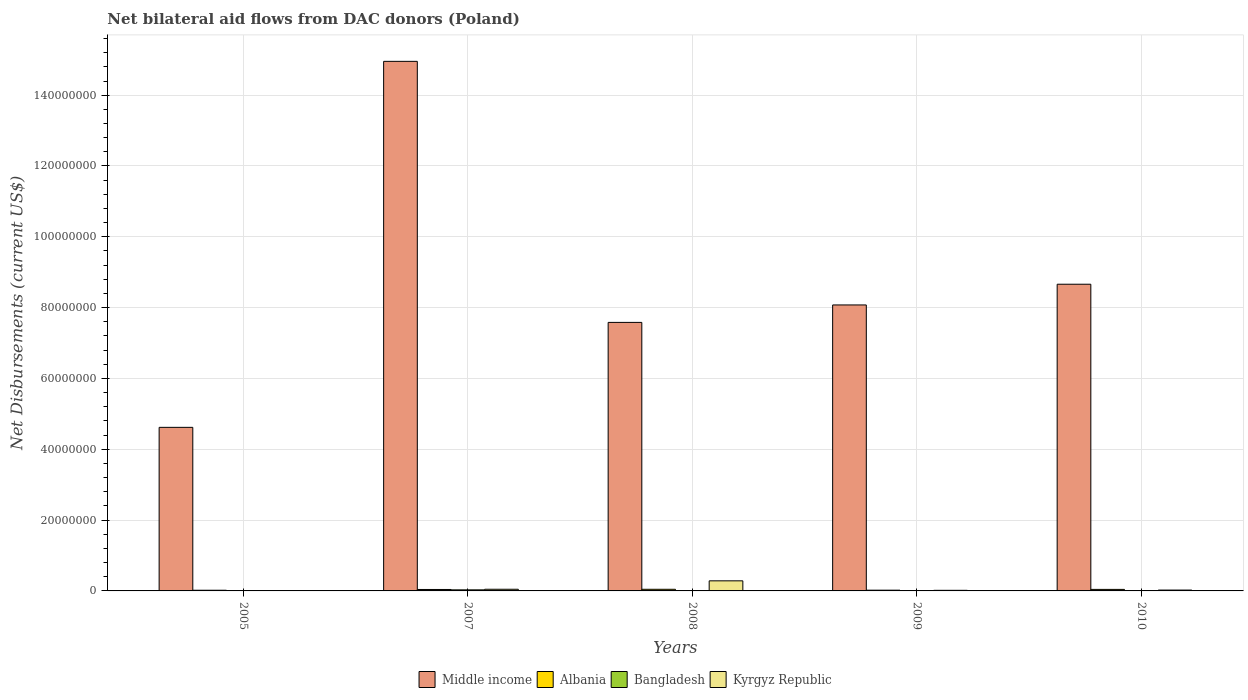How many different coloured bars are there?
Give a very brief answer. 4. How many groups of bars are there?
Keep it short and to the point. 5. Are the number of bars on each tick of the X-axis equal?
Your answer should be very brief. Yes. In how many cases, is the number of bars for a given year not equal to the number of legend labels?
Ensure brevity in your answer.  0. What is the net bilateral aid flows in Kyrgyz Republic in 2010?
Your answer should be compact. 2.40e+05. Across all years, what is the maximum net bilateral aid flows in Middle income?
Keep it short and to the point. 1.50e+08. Across all years, what is the minimum net bilateral aid flows in Albania?
Your answer should be compact. 1.90e+05. In which year was the net bilateral aid flows in Middle income maximum?
Your response must be concise. 2007. In which year was the net bilateral aid flows in Bangladesh minimum?
Give a very brief answer. 2005. What is the total net bilateral aid flows in Albania in the graph?
Offer a very short reply. 1.70e+06. What is the difference between the net bilateral aid flows in Middle income in 2008 and that in 2009?
Make the answer very short. -4.93e+06. What is the difference between the net bilateral aid flows in Kyrgyz Republic in 2007 and the net bilateral aid flows in Bangladesh in 2010?
Give a very brief answer. 4.20e+05. What is the average net bilateral aid flows in Bangladesh per year?
Ensure brevity in your answer.  9.60e+04. In the year 2009, what is the difference between the net bilateral aid flows in Albania and net bilateral aid flows in Middle income?
Ensure brevity in your answer.  -8.06e+07. In how many years, is the net bilateral aid flows in Albania greater than 52000000 US$?
Your response must be concise. 0. What is the ratio of the net bilateral aid flows in Bangladesh in 2007 to that in 2008?
Ensure brevity in your answer.  4.29. Is the net bilateral aid flows in Kyrgyz Republic in 2007 less than that in 2010?
Make the answer very short. No. Is the difference between the net bilateral aid flows in Albania in 2005 and 2007 greater than the difference between the net bilateral aid flows in Middle income in 2005 and 2007?
Give a very brief answer. Yes. Is the sum of the net bilateral aid flows in Middle income in 2009 and 2010 greater than the maximum net bilateral aid flows in Albania across all years?
Make the answer very short. Yes. What does the 2nd bar from the left in 2010 represents?
Provide a succinct answer. Albania. What does the 3rd bar from the right in 2008 represents?
Give a very brief answer. Albania. How many bars are there?
Offer a very short reply. 20. How many years are there in the graph?
Give a very brief answer. 5. Are the values on the major ticks of Y-axis written in scientific E-notation?
Make the answer very short. No. Does the graph contain grids?
Your answer should be very brief. Yes. How many legend labels are there?
Your response must be concise. 4. How are the legend labels stacked?
Your response must be concise. Horizontal. What is the title of the graph?
Keep it short and to the point. Net bilateral aid flows from DAC donors (Poland). Does "Tanzania" appear as one of the legend labels in the graph?
Offer a very short reply. No. What is the label or title of the X-axis?
Your answer should be compact. Years. What is the label or title of the Y-axis?
Ensure brevity in your answer.  Net Disbursements (current US$). What is the Net Disbursements (current US$) of Middle income in 2005?
Provide a succinct answer. 4.62e+07. What is the Net Disbursements (current US$) of Middle income in 2007?
Provide a succinct answer. 1.50e+08. What is the Net Disbursements (current US$) of Bangladesh in 2007?
Provide a succinct answer. 3.00e+05. What is the Net Disbursements (current US$) of Middle income in 2008?
Offer a terse response. 7.58e+07. What is the Net Disbursements (current US$) of Albania in 2008?
Provide a short and direct response. 4.60e+05. What is the Net Disbursements (current US$) of Kyrgyz Republic in 2008?
Provide a succinct answer. 2.85e+06. What is the Net Disbursements (current US$) in Middle income in 2009?
Keep it short and to the point. 8.08e+07. What is the Net Disbursements (current US$) of Middle income in 2010?
Provide a succinct answer. 8.66e+07. What is the Net Disbursements (current US$) of Albania in 2010?
Your response must be concise. 4.30e+05. What is the Net Disbursements (current US$) of Kyrgyz Republic in 2010?
Offer a terse response. 2.40e+05. Across all years, what is the maximum Net Disbursements (current US$) in Middle income?
Provide a succinct answer. 1.50e+08. Across all years, what is the maximum Net Disbursements (current US$) of Kyrgyz Republic?
Your answer should be very brief. 2.85e+06. Across all years, what is the minimum Net Disbursements (current US$) of Middle income?
Give a very brief answer. 4.62e+07. Across all years, what is the minimum Net Disbursements (current US$) of Kyrgyz Republic?
Provide a short and direct response. 7.00e+04. What is the total Net Disbursements (current US$) of Middle income in the graph?
Your response must be concise. 4.39e+08. What is the total Net Disbursements (current US$) in Albania in the graph?
Your answer should be compact. 1.70e+06. What is the total Net Disbursements (current US$) in Kyrgyz Republic in the graph?
Offer a very short reply. 3.80e+06. What is the difference between the Net Disbursements (current US$) of Middle income in 2005 and that in 2007?
Offer a terse response. -1.03e+08. What is the difference between the Net Disbursements (current US$) in Bangladesh in 2005 and that in 2007?
Provide a succinct answer. -2.90e+05. What is the difference between the Net Disbursements (current US$) of Kyrgyz Republic in 2005 and that in 2007?
Give a very brief answer. -4.00e+05. What is the difference between the Net Disbursements (current US$) of Middle income in 2005 and that in 2008?
Give a very brief answer. -2.96e+07. What is the difference between the Net Disbursements (current US$) of Albania in 2005 and that in 2008?
Keep it short and to the point. -2.70e+05. What is the difference between the Net Disbursements (current US$) in Bangladesh in 2005 and that in 2008?
Your answer should be compact. -6.00e+04. What is the difference between the Net Disbursements (current US$) of Kyrgyz Republic in 2005 and that in 2008?
Make the answer very short. -2.78e+06. What is the difference between the Net Disbursements (current US$) of Middle income in 2005 and that in 2009?
Offer a terse response. -3.46e+07. What is the difference between the Net Disbursements (current US$) of Albania in 2005 and that in 2009?
Your answer should be very brief. -2.00e+04. What is the difference between the Net Disbursements (current US$) in Bangladesh in 2005 and that in 2009?
Your response must be concise. -4.00e+04. What is the difference between the Net Disbursements (current US$) of Middle income in 2005 and that in 2010?
Offer a terse response. -4.04e+07. What is the difference between the Net Disbursements (current US$) in Albania in 2005 and that in 2010?
Give a very brief answer. -2.40e+05. What is the difference between the Net Disbursements (current US$) in Middle income in 2007 and that in 2008?
Give a very brief answer. 7.37e+07. What is the difference between the Net Disbursements (current US$) in Albania in 2007 and that in 2008?
Offer a very short reply. -5.00e+04. What is the difference between the Net Disbursements (current US$) of Bangladesh in 2007 and that in 2008?
Your answer should be very brief. 2.30e+05. What is the difference between the Net Disbursements (current US$) in Kyrgyz Republic in 2007 and that in 2008?
Keep it short and to the point. -2.38e+06. What is the difference between the Net Disbursements (current US$) of Middle income in 2007 and that in 2009?
Your answer should be compact. 6.88e+07. What is the difference between the Net Disbursements (current US$) of Kyrgyz Republic in 2007 and that in 2009?
Offer a very short reply. 3.00e+05. What is the difference between the Net Disbursements (current US$) of Middle income in 2007 and that in 2010?
Keep it short and to the point. 6.29e+07. What is the difference between the Net Disbursements (current US$) of Albania in 2007 and that in 2010?
Provide a succinct answer. -2.00e+04. What is the difference between the Net Disbursements (current US$) of Bangladesh in 2007 and that in 2010?
Your answer should be compact. 2.50e+05. What is the difference between the Net Disbursements (current US$) of Middle income in 2008 and that in 2009?
Your answer should be very brief. -4.93e+06. What is the difference between the Net Disbursements (current US$) of Albania in 2008 and that in 2009?
Your answer should be very brief. 2.50e+05. What is the difference between the Net Disbursements (current US$) of Bangladesh in 2008 and that in 2009?
Your answer should be compact. 2.00e+04. What is the difference between the Net Disbursements (current US$) of Kyrgyz Republic in 2008 and that in 2009?
Keep it short and to the point. 2.68e+06. What is the difference between the Net Disbursements (current US$) of Middle income in 2008 and that in 2010?
Provide a short and direct response. -1.08e+07. What is the difference between the Net Disbursements (current US$) of Albania in 2008 and that in 2010?
Offer a terse response. 3.00e+04. What is the difference between the Net Disbursements (current US$) of Kyrgyz Republic in 2008 and that in 2010?
Your answer should be compact. 2.61e+06. What is the difference between the Net Disbursements (current US$) in Middle income in 2009 and that in 2010?
Provide a short and direct response. -5.85e+06. What is the difference between the Net Disbursements (current US$) in Kyrgyz Republic in 2009 and that in 2010?
Provide a short and direct response. -7.00e+04. What is the difference between the Net Disbursements (current US$) of Middle income in 2005 and the Net Disbursements (current US$) of Albania in 2007?
Make the answer very short. 4.58e+07. What is the difference between the Net Disbursements (current US$) in Middle income in 2005 and the Net Disbursements (current US$) in Bangladesh in 2007?
Your answer should be compact. 4.59e+07. What is the difference between the Net Disbursements (current US$) of Middle income in 2005 and the Net Disbursements (current US$) of Kyrgyz Republic in 2007?
Give a very brief answer. 4.57e+07. What is the difference between the Net Disbursements (current US$) in Albania in 2005 and the Net Disbursements (current US$) in Kyrgyz Republic in 2007?
Keep it short and to the point. -2.80e+05. What is the difference between the Net Disbursements (current US$) in Bangladesh in 2005 and the Net Disbursements (current US$) in Kyrgyz Republic in 2007?
Your response must be concise. -4.60e+05. What is the difference between the Net Disbursements (current US$) of Middle income in 2005 and the Net Disbursements (current US$) of Albania in 2008?
Offer a very short reply. 4.57e+07. What is the difference between the Net Disbursements (current US$) in Middle income in 2005 and the Net Disbursements (current US$) in Bangladesh in 2008?
Give a very brief answer. 4.61e+07. What is the difference between the Net Disbursements (current US$) of Middle income in 2005 and the Net Disbursements (current US$) of Kyrgyz Republic in 2008?
Ensure brevity in your answer.  4.33e+07. What is the difference between the Net Disbursements (current US$) in Albania in 2005 and the Net Disbursements (current US$) in Kyrgyz Republic in 2008?
Give a very brief answer. -2.66e+06. What is the difference between the Net Disbursements (current US$) in Bangladesh in 2005 and the Net Disbursements (current US$) in Kyrgyz Republic in 2008?
Offer a terse response. -2.84e+06. What is the difference between the Net Disbursements (current US$) in Middle income in 2005 and the Net Disbursements (current US$) in Albania in 2009?
Your response must be concise. 4.60e+07. What is the difference between the Net Disbursements (current US$) of Middle income in 2005 and the Net Disbursements (current US$) of Bangladesh in 2009?
Offer a terse response. 4.61e+07. What is the difference between the Net Disbursements (current US$) of Middle income in 2005 and the Net Disbursements (current US$) of Kyrgyz Republic in 2009?
Your answer should be very brief. 4.60e+07. What is the difference between the Net Disbursements (current US$) in Middle income in 2005 and the Net Disbursements (current US$) in Albania in 2010?
Offer a very short reply. 4.58e+07. What is the difference between the Net Disbursements (current US$) of Middle income in 2005 and the Net Disbursements (current US$) of Bangladesh in 2010?
Offer a terse response. 4.61e+07. What is the difference between the Net Disbursements (current US$) of Middle income in 2005 and the Net Disbursements (current US$) of Kyrgyz Republic in 2010?
Offer a terse response. 4.60e+07. What is the difference between the Net Disbursements (current US$) in Albania in 2005 and the Net Disbursements (current US$) in Kyrgyz Republic in 2010?
Offer a very short reply. -5.00e+04. What is the difference between the Net Disbursements (current US$) of Middle income in 2007 and the Net Disbursements (current US$) of Albania in 2008?
Offer a very short reply. 1.49e+08. What is the difference between the Net Disbursements (current US$) in Middle income in 2007 and the Net Disbursements (current US$) in Bangladesh in 2008?
Offer a very short reply. 1.49e+08. What is the difference between the Net Disbursements (current US$) of Middle income in 2007 and the Net Disbursements (current US$) of Kyrgyz Republic in 2008?
Your response must be concise. 1.47e+08. What is the difference between the Net Disbursements (current US$) in Albania in 2007 and the Net Disbursements (current US$) in Bangladesh in 2008?
Your response must be concise. 3.40e+05. What is the difference between the Net Disbursements (current US$) of Albania in 2007 and the Net Disbursements (current US$) of Kyrgyz Republic in 2008?
Make the answer very short. -2.44e+06. What is the difference between the Net Disbursements (current US$) in Bangladesh in 2007 and the Net Disbursements (current US$) in Kyrgyz Republic in 2008?
Provide a short and direct response. -2.55e+06. What is the difference between the Net Disbursements (current US$) in Middle income in 2007 and the Net Disbursements (current US$) in Albania in 2009?
Ensure brevity in your answer.  1.49e+08. What is the difference between the Net Disbursements (current US$) in Middle income in 2007 and the Net Disbursements (current US$) in Bangladesh in 2009?
Provide a succinct answer. 1.50e+08. What is the difference between the Net Disbursements (current US$) in Middle income in 2007 and the Net Disbursements (current US$) in Kyrgyz Republic in 2009?
Offer a terse response. 1.49e+08. What is the difference between the Net Disbursements (current US$) in Middle income in 2007 and the Net Disbursements (current US$) in Albania in 2010?
Make the answer very short. 1.49e+08. What is the difference between the Net Disbursements (current US$) in Middle income in 2007 and the Net Disbursements (current US$) in Bangladesh in 2010?
Offer a very short reply. 1.50e+08. What is the difference between the Net Disbursements (current US$) in Middle income in 2007 and the Net Disbursements (current US$) in Kyrgyz Republic in 2010?
Provide a short and direct response. 1.49e+08. What is the difference between the Net Disbursements (current US$) of Albania in 2007 and the Net Disbursements (current US$) of Kyrgyz Republic in 2010?
Keep it short and to the point. 1.70e+05. What is the difference between the Net Disbursements (current US$) of Bangladesh in 2007 and the Net Disbursements (current US$) of Kyrgyz Republic in 2010?
Your answer should be compact. 6.00e+04. What is the difference between the Net Disbursements (current US$) of Middle income in 2008 and the Net Disbursements (current US$) of Albania in 2009?
Your answer should be compact. 7.56e+07. What is the difference between the Net Disbursements (current US$) of Middle income in 2008 and the Net Disbursements (current US$) of Bangladesh in 2009?
Your answer should be compact. 7.58e+07. What is the difference between the Net Disbursements (current US$) in Middle income in 2008 and the Net Disbursements (current US$) in Kyrgyz Republic in 2009?
Keep it short and to the point. 7.57e+07. What is the difference between the Net Disbursements (current US$) in Albania in 2008 and the Net Disbursements (current US$) in Bangladesh in 2009?
Your answer should be very brief. 4.10e+05. What is the difference between the Net Disbursements (current US$) of Albania in 2008 and the Net Disbursements (current US$) of Kyrgyz Republic in 2009?
Keep it short and to the point. 2.90e+05. What is the difference between the Net Disbursements (current US$) of Bangladesh in 2008 and the Net Disbursements (current US$) of Kyrgyz Republic in 2009?
Your response must be concise. -1.00e+05. What is the difference between the Net Disbursements (current US$) in Middle income in 2008 and the Net Disbursements (current US$) in Albania in 2010?
Your response must be concise. 7.54e+07. What is the difference between the Net Disbursements (current US$) of Middle income in 2008 and the Net Disbursements (current US$) of Bangladesh in 2010?
Your response must be concise. 7.58e+07. What is the difference between the Net Disbursements (current US$) in Middle income in 2008 and the Net Disbursements (current US$) in Kyrgyz Republic in 2010?
Offer a terse response. 7.56e+07. What is the difference between the Net Disbursements (current US$) of Bangladesh in 2008 and the Net Disbursements (current US$) of Kyrgyz Republic in 2010?
Offer a very short reply. -1.70e+05. What is the difference between the Net Disbursements (current US$) of Middle income in 2009 and the Net Disbursements (current US$) of Albania in 2010?
Your answer should be very brief. 8.03e+07. What is the difference between the Net Disbursements (current US$) in Middle income in 2009 and the Net Disbursements (current US$) in Bangladesh in 2010?
Provide a short and direct response. 8.07e+07. What is the difference between the Net Disbursements (current US$) in Middle income in 2009 and the Net Disbursements (current US$) in Kyrgyz Republic in 2010?
Offer a very short reply. 8.05e+07. What is the difference between the Net Disbursements (current US$) in Albania in 2009 and the Net Disbursements (current US$) in Bangladesh in 2010?
Your answer should be compact. 1.60e+05. What is the difference between the Net Disbursements (current US$) in Bangladesh in 2009 and the Net Disbursements (current US$) in Kyrgyz Republic in 2010?
Offer a very short reply. -1.90e+05. What is the average Net Disbursements (current US$) in Middle income per year?
Your answer should be compact. 8.78e+07. What is the average Net Disbursements (current US$) of Albania per year?
Keep it short and to the point. 3.40e+05. What is the average Net Disbursements (current US$) of Bangladesh per year?
Keep it short and to the point. 9.60e+04. What is the average Net Disbursements (current US$) in Kyrgyz Republic per year?
Provide a short and direct response. 7.60e+05. In the year 2005, what is the difference between the Net Disbursements (current US$) of Middle income and Net Disbursements (current US$) of Albania?
Keep it short and to the point. 4.60e+07. In the year 2005, what is the difference between the Net Disbursements (current US$) of Middle income and Net Disbursements (current US$) of Bangladesh?
Provide a short and direct response. 4.62e+07. In the year 2005, what is the difference between the Net Disbursements (current US$) of Middle income and Net Disbursements (current US$) of Kyrgyz Republic?
Your answer should be compact. 4.61e+07. In the year 2005, what is the difference between the Net Disbursements (current US$) of Bangladesh and Net Disbursements (current US$) of Kyrgyz Republic?
Offer a very short reply. -6.00e+04. In the year 2007, what is the difference between the Net Disbursements (current US$) in Middle income and Net Disbursements (current US$) in Albania?
Your response must be concise. 1.49e+08. In the year 2007, what is the difference between the Net Disbursements (current US$) of Middle income and Net Disbursements (current US$) of Bangladesh?
Offer a very short reply. 1.49e+08. In the year 2007, what is the difference between the Net Disbursements (current US$) in Middle income and Net Disbursements (current US$) in Kyrgyz Republic?
Offer a terse response. 1.49e+08. In the year 2007, what is the difference between the Net Disbursements (current US$) of Bangladesh and Net Disbursements (current US$) of Kyrgyz Republic?
Ensure brevity in your answer.  -1.70e+05. In the year 2008, what is the difference between the Net Disbursements (current US$) in Middle income and Net Disbursements (current US$) in Albania?
Provide a succinct answer. 7.54e+07. In the year 2008, what is the difference between the Net Disbursements (current US$) of Middle income and Net Disbursements (current US$) of Bangladesh?
Ensure brevity in your answer.  7.58e+07. In the year 2008, what is the difference between the Net Disbursements (current US$) in Middle income and Net Disbursements (current US$) in Kyrgyz Republic?
Your answer should be compact. 7.30e+07. In the year 2008, what is the difference between the Net Disbursements (current US$) in Albania and Net Disbursements (current US$) in Bangladesh?
Your answer should be very brief. 3.90e+05. In the year 2008, what is the difference between the Net Disbursements (current US$) in Albania and Net Disbursements (current US$) in Kyrgyz Republic?
Your response must be concise. -2.39e+06. In the year 2008, what is the difference between the Net Disbursements (current US$) in Bangladesh and Net Disbursements (current US$) in Kyrgyz Republic?
Your answer should be very brief. -2.78e+06. In the year 2009, what is the difference between the Net Disbursements (current US$) of Middle income and Net Disbursements (current US$) of Albania?
Your answer should be very brief. 8.06e+07. In the year 2009, what is the difference between the Net Disbursements (current US$) in Middle income and Net Disbursements (current US$) in Bangladesh?
Your answer should be compact. 8.07e+07. In the year 2009, what is the difference between the Net Disbursements (current US$) in Middle income and Net Disbursements (current US$) in Kyrgyz Republic?
Provide a succinct answer. 8.06e+07. In the year 2009, what is the difference between the Net Disbursements (current US$) in Albania and Net Disbursements (current US$) in Bangladesh?
Your answer should be compact. 1.60e+05. In the year 2009, what is the difference between the Net Disbursements (current US$) in Albania and Net Disbursements (current US$) in Kyrgyz Republic?
Offer a terse response. 4.00e+04. In the year 2009, what is the difference between the Net Disbursements (current US$) of Bangladesh and Net Disbursements (current US$) of Kyrgyz Republic?
Make the answer very short. -1.20e+05. In the year 2010, what is the difference between the Net Disbursements (current US$) in Middle income and Net Disbursements (current US$) in Albania?
Make the answer very short. 8.62e+07. In the year 2010, what is the difference between the Net Disbursements (current US$) of Middle income and Net Disbursements (current US$) of Bangladesh?
Offer a terse response. 8.66e+07. In the year 2010, what is the difference between the Net Disbursements (current US$) of Middle income and Net Disbursements (current US$) of Kyrgyz Republic?
Your response must be concise. 8.64e+07. In the year 2010, what is the difference between the Net Disbursements (current US$) in Albania and Net Disbursements (current US$) in Kyrgyz Republic?
Keep it short and to the point. 1.90e+05. What is the ratio of the Net Disbursements (current US$) of Middle income in 2005 to that in 2007?
Provide a short and direct response. 0.31. What is the ratio of the Net Disbursements (current US$) in Albania in 2005 to that in 2007?
Keep it short and to the point. 0.46. What is the ratio of the Net Disbursements (current US$) in Bangladesh in 2005 to that in 2007?
Ensure brevity in your answer.  0.03. What is the ratio of the Net Disbursements (current US$) of Kyrgyz Republic in 2005 to that in 2007?
Your answer should be very brief. 0.15. What is the ratio of the Net Disbursements (current US$) of Middle income in 2005 to that in 2008?
Provide a succinct answer. 0.61. What is the ratio of the Net Disbursements (current US$) of Albania in 2005 to that in 2008?
Provide a short and direct response. 0.41. What is the ratio of the Net Disbursements (current US$) in Bangladesh in 2005 to that in 2008?
Provide a succinct answer. 0.14. What is the ratio of the Net Disbursements (current US$) in Kyrgyz Republic in 2005 to that in 2008?
Make the answer very short. 0.02. What is the ratio of the Net Disbursements (current US$) of Middle income in 2005 to that in 2009?
Offer a very short reply. 0.57. What is the ratio of the Net Disbursements (current US$) of Albania in 2005 to that in 2009?
Provide a short and direct response. 0.9. What is the ratio of the Net Disbursements (current US$) in Bangladesh in 2005 to that in 2009?
Keep it short and to the point. 0.2. What is the ratio of the Net Disbursements (current US$) in Kyrgyz Republic in 2005 to that in 2009?
Offer a terse response. 0.41. What is the ratio of the Net Disbursements (current US$) in Middle income in 2005 to that in 2010?
Your response must be concise. 0.53. What is the ratio of the Net Disbursements (current US$) in Albania in 2005 to that in 2010?
Your answer should be compact. 0.44. What is the ratio of the Net Disbursements (current US$) of Kyrgyz Republic in 2005 to that in 2010?
Make the answer very short. 0.29. What is the ratio of the Net Disbursements (current US$) of Middle income in 2007 to that in 2008?
Your response must be concise. 1.97. What is the ratio of the Net Disbursements (current US$) of Albania in 2007 to that in 2008?
Provide a succinct answer. 0.89. What is the ratio of the Net Disbursements (current US$) of Bangladesh in 2007 to that in 2008?
Your response must be concise. 4.29. What is the ratio of the Net Disbursements (current US$) of Kyrgyz Republic in 2007 to that in 2008?
Ensure brevity in your answer.  0.16. What is the ratio of the Net Disbursements (current US$) of Middle income in 2007 to that in 2009?
Offer a terse response. 1.85. What is the ratio of the Net Disbursements (current US$) of Albania in 2007 to that in 2009?
Ensure brevity in your answer.  1.95. What is the ratio of the Net Disbursements (current US$) of Bangladesh in 2007 to that in 2009?
Make the answer very short. 6. What is the ratio of the Net Disbursements (current US$) of Kyrgyz Republic in 2007 to that in 2009?
Make the answer very short. 2.76. What is the ratio of the Net Disbursements (current US$) of Middle income in 2007 to that in 2010?
Your answer should be very brief. 1.73. What is the ratio of the Net Disbursements (current US$) in Albania in 2007 to that in 2010?
Your answer should be compact. 0.95. What is the ratio of the Net Disbursements (current US$) of Kyrgyz Republic in 2007 to that in 2010?
Your response must be concise. 1.96. What is the ratio of the Net Disbursements (current US$) of Middle income in 2008 to that in 2009?
Your answer should be compact. 0.94. What is the ratio of the Net Disbursements (current US$) in Albania in 2008 to that in 2009?
Offer a terse response. 2.19. What is the ratio of the Net Disbursements (current US$) in Bangladesh in 2008 to that in 2009?
Your answer should be very brief. 1.4. What is the ratio of the Net Disbursements (current US$) in Kyrgyz Republic in 2008 to that in 2009?
Give a very brief answer. 16.76. What is the ratio of the Net Disbursements (current US$) of Middle income in 2008 to that in 2010?
Ensure brevity in your answer.  0.88. What is the ratio of the Net Disbursements (current US$) in Albania in 2008 to that in 2010?
Offer a terse response. 1.07. What is the ratio of the Net Disbursements (current US$) in Bangladesh in 2008 to that in 2010?
Your answer should be compact. 1.4. What is the ratio of the Net Disbursements (current US$) of Kyrgyz Republic in 2008 to that in 2010?
Ensure brevity in your answer.  11.88. What is the ratio of the Net Disbursements (current US$) in Middle income in 2009 to that in 2010?
Provide a short and direct response. 0.93. What is the ratio of the Net Disbursements (current US$) in Albania in 2009 to that in 2010?
Offer a very short reply. 0.49. What is the ratio of the Net Disbursements (current US$) of Bangladesh in 2009 to that in 2010?
Ensure brevity in your answer.  1. What is the ratio of the Net Disbursements (current US$) in Kyrgyz Republic in 2009 to that in 2010?
Make the answer very short. 0.71. What is the difference between the highest and the second highest Net Disbursements (current US$) in Middle income?
Make the answer very short. 6.29e+07. What is the difference between the highest and the second highest Net Disbursements (current US$) of Kyrgyz Republic?
Give a very brief answer. 2.38e+06. What is the difference between the highest and the lowest Net Disbursements (current US$) in Middle income?
Make the answer very short. 1.03e+08. What is the difference between the highest and the lowest Net Disbursements (current US$) of Kyrgyz Republic?
Give a very brief answer. 2.78e+06. 